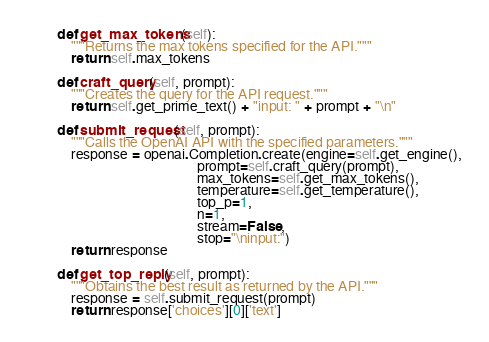<code> <loc_0><loc_0><loc_500><loc_500><_Python_>
    def get_max_tokens(self):
        """Returns the max tokens specified for the API."""
        return self.max_tokens

    def craft_query(self, prompt):
        """Creates the query for the API request."""
        return self.get_prime_text() + "input: " + prompt + "\n"

    def submit_request(self, prompt):
        """Calls the OpenAI API with the specified parameters."""
        response = openai.Completion.create(engine=self.get_engine(),
                                            prompt=self.craft_query(prompt),
                                            max_tokens=self.get_max_tokens(),
                                            temperature=self.get_temperature(),
                                            top_p=1,
                                            n=1,
                                            stream=False,
                                            stop="\ninput:")
        return response

    def get_top_reply(self, prompt):
        """Obtains the best result as returned by the API."""
        response = self.submit_request(prompt)
        return response['choices'][0]['text']
</code> 